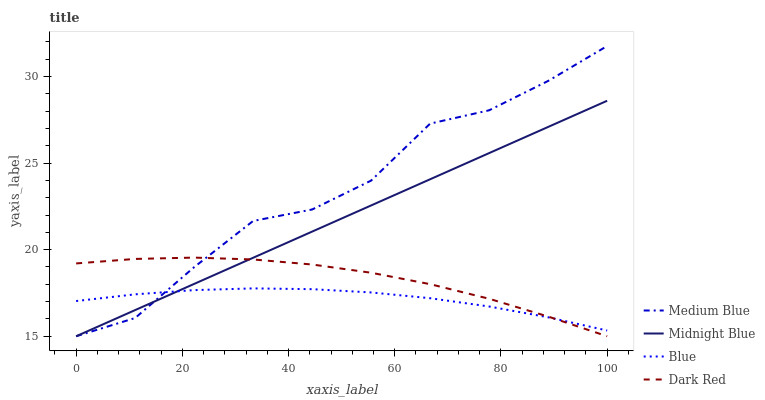Does Blue have the minimum area under the curve?
Answer yes or no. Yes. Does Medium Blue have the maximum area under the curve?
Answer yes or no. Yes. Does Dark Red have the minimum area under the curve?
Answer yes or no. No. Does Dark Red have the maximum area under the curve?
Answer yes or no. No. Is Midnight Blue the smoothest?
Answer yes or no. Yes. Is Medium Blue the roughest?
Answer yes or no. Yes. Is Dark Red the smoothest?
Answer yes or no. No. Is Dark Red the roughest?
Answer yes or no. No. Does Dark Red have the lowest value?
Answer yes or no. Yes. Does Medium Blue have the highest value?
Answer yes or no. Yes. Does Dark Red have the highest value?
Answer yes or no. No. Does Dark Red intersect Midnight Blue?
Answer yes or no. Yes. Is Dark Red less than Midnight Blue?
Answer yes or no. No. Is Dark Red greater than Midnight Blue?
Answer yes or no. No. 